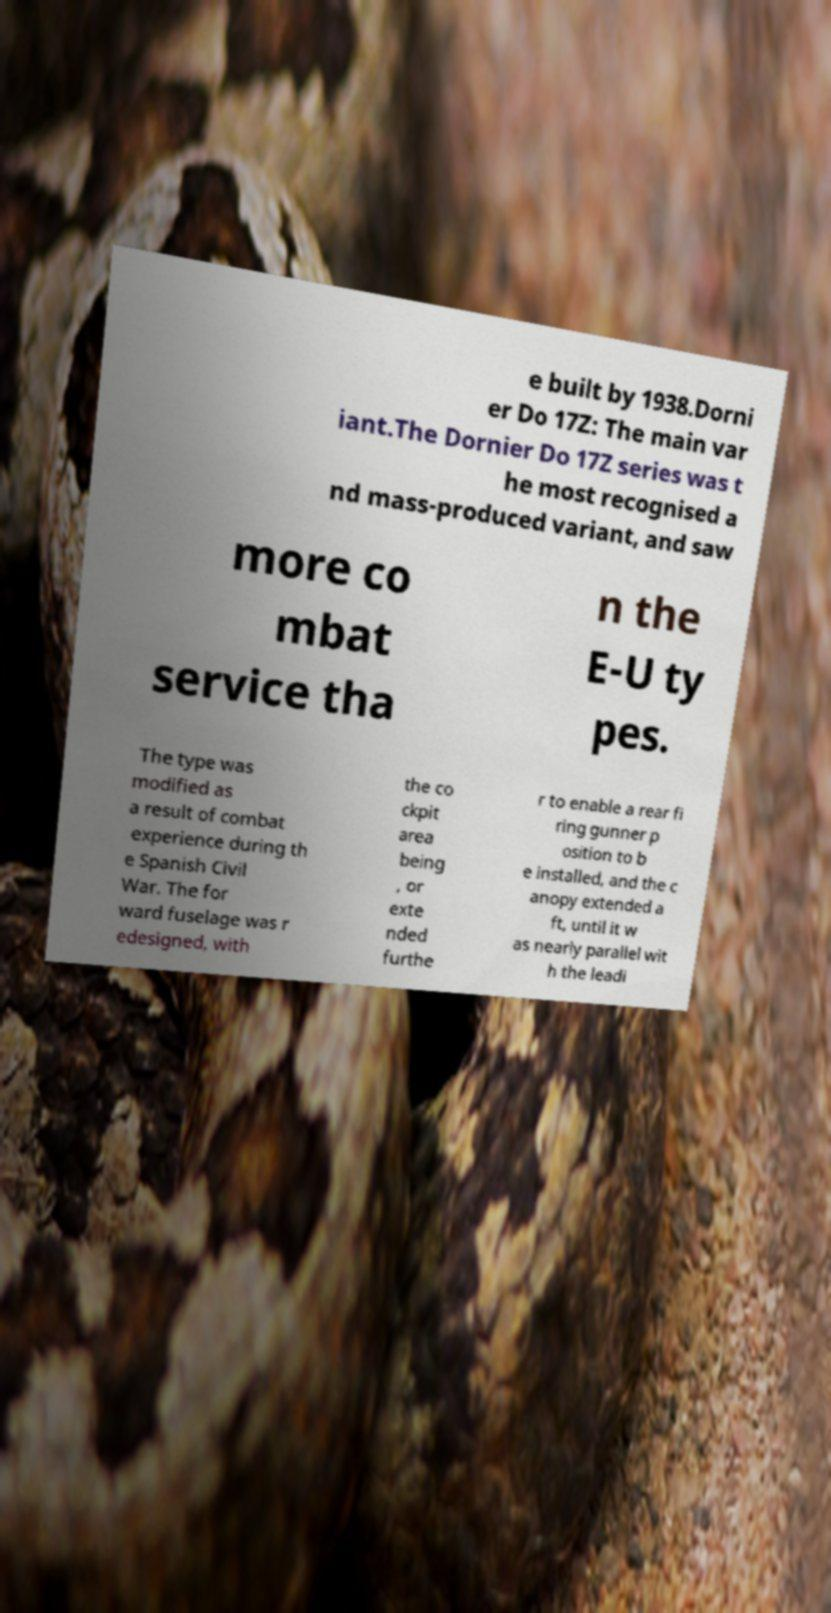Can you read and provide the text displayed in the image?This photo seems to have some interesting text. Can you extract and type it out for me? e built by 1938.Dorni er Do 17Z: The main var iant.The Dornier Do 17Z series was t he most recognised a nd mass-produced variant, and saw more co mbat service tha n the E-U ty pes. The type was modified as a result of combat experience during th e Spanish Civil War. The for ward fuselage was r edesigned, with the co ckpit area being , or exte nded furthe r to enable a rear fi ring gunner p osition to b e installed, and the c anopy extended a ft, until it w as nearly parallel wit h the leadi 